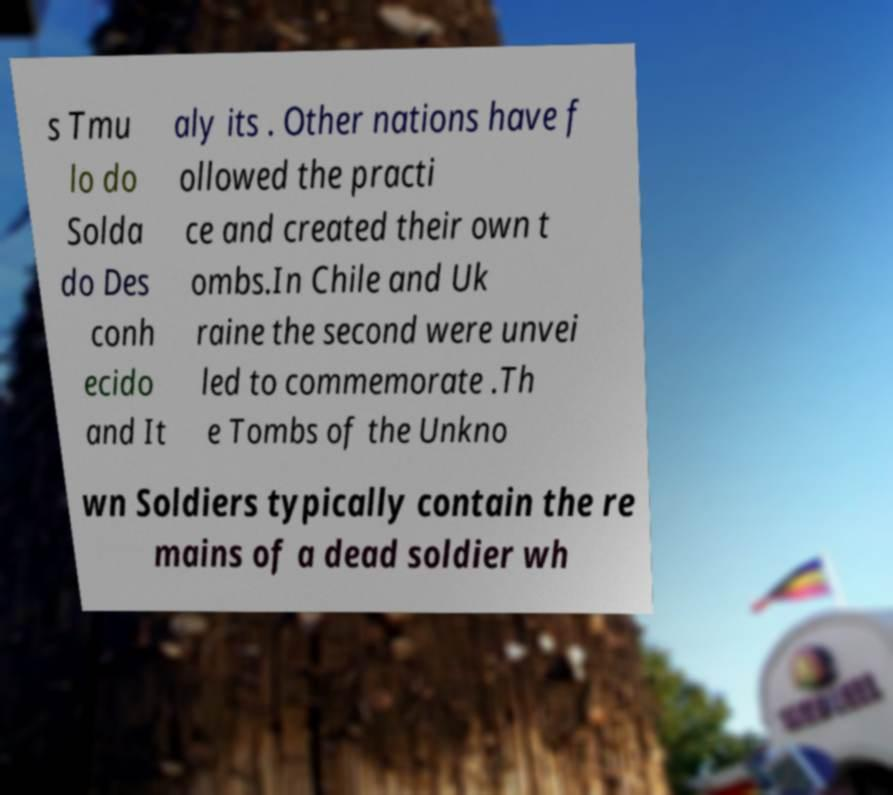Could you extract and type out the text from this image? s Tmu lo do Solda do Des conh ecido and It aly its . Other nations have f ollowed the practi ce and created their own t ombs.In Chile and Uk raine the second were unvei led to commemorate .Th e Tombs of the Unkno wn Soldiers typically contain the re mains of a dead soldier wh 